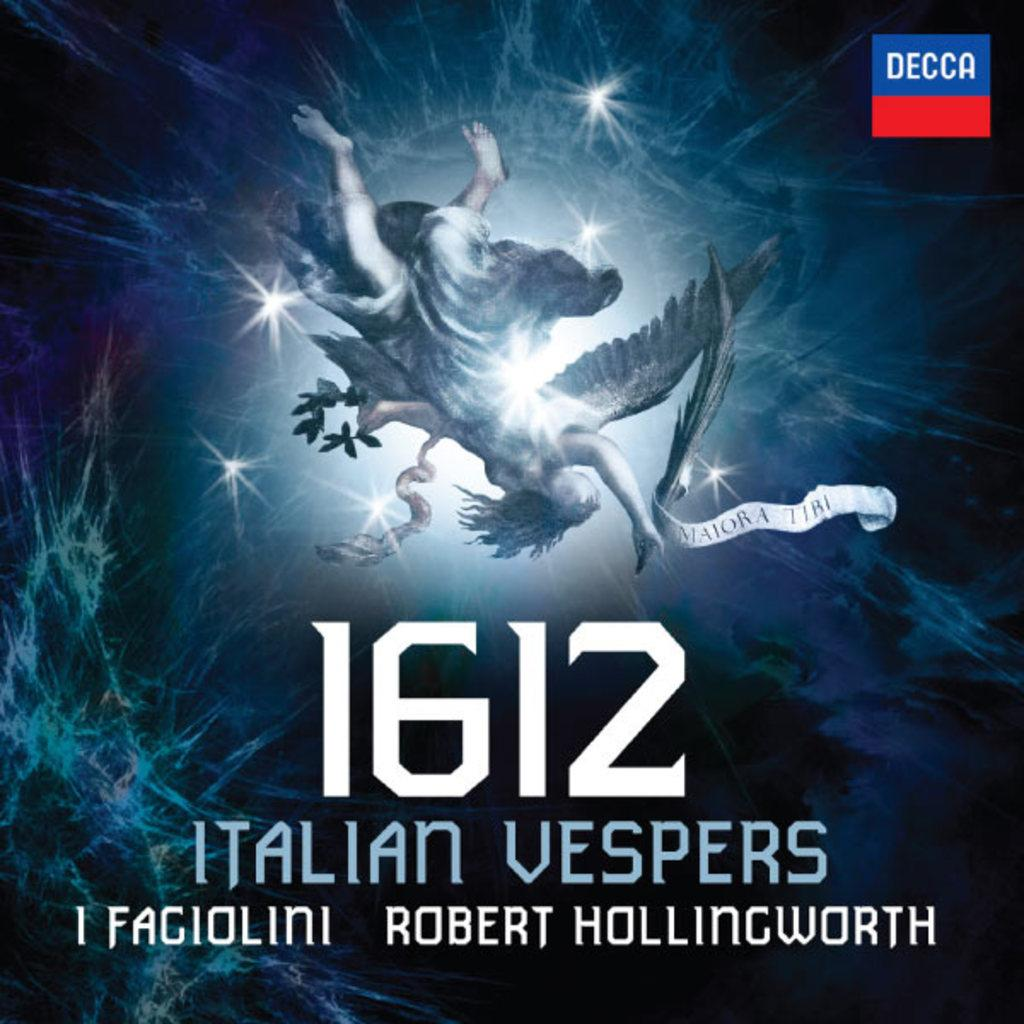Provide a one-sentence caption for the provided image. 1612 Italian vespers 1 fagiolini by Robert Hollingworth. 